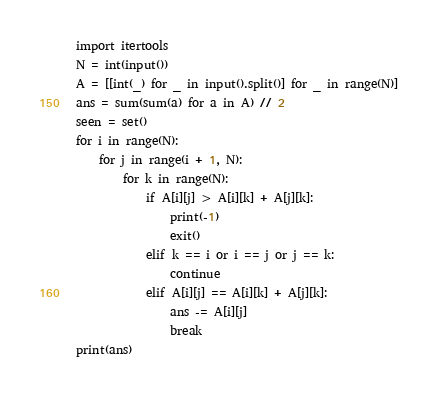<code> <loc_0><loc_0><loc_500><loc_500><_Python_>import itertools
N = int(input())
A = [[int(_) for _ in input().split()] for _ in range(N)]
ans = sum(sum(a) for a in A) // 2
seen = set()
for i in range(N):
    for j in range(i + 1, N):
        for k in range(N):
            if A[i][j] > A[i][k] + A[j][k]:
                print(-1)
                exit()
            elif k == i or i == j or j == k:
                continue
            elif A[i][j] == A[i][k] + A[j][k]:
                ans -= A[i][j]
                break
print(ans)
</code> 